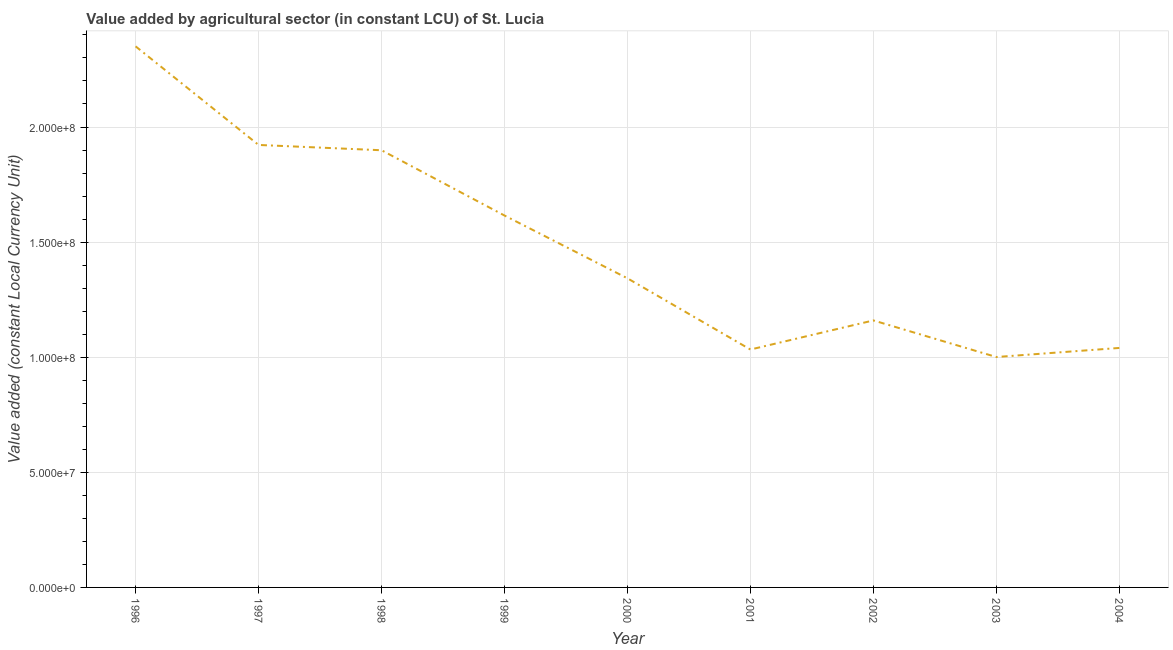What is the value added by agriculture sector in 2001?
Offer a very short reply. 1.03e+08. Across all years, what is the maximum value added by agriculture sector?
Offer a very short reply. 2.35e+08. Across all years, what is the minimum value added by agriculture sector?
Your answer should be compact. 1.00e+08. In which year was the value added by agriculture sector maximum?
Provide a short and direct response. 1996. What is the sum of the value added by agriculture sector?
Offer a terse response. 1.34e+09. What is the difference between the value added by agriculture sector in 1999 and 2000?
Your answer should be very brief. 2.73e+07. What is the average value added by agriculture sector per year?
Provide a short and direct response. 1.48e+08. What is the median value added by agriculture sector?
Your answer should be compact. 1.34e+08. In how many years, is the value added by agriculture sector greater than 160000000 LCU?
Keep it short and to the point. 4. Do a majority of the years between 1999 and 1997 (inclusive) have value added by agriculture sector greater than 190000000 LCU?
Your answer should be compact. No. What is the ratio of the value added by agriculture sector in 1998 to that in 2004?
Offer a terse response. 1.83. Is the difference between the value added by agriculture sector in 1998 and 2004 greater than the difference between any two years?
Your response must be concise. No. What is the difference between the highest and the second highest value added by agriculture sector?
Give a very brief answer. 4.28e+07. Is the sum of the value added by agriculture sector in 1997 and 1999 greater than the maximum value added by agriculture sector across all years?
Make the answer very short. Yes. What is the difference between the highest and the lowest value added by agriculture sector?
Your response must be concise. 1.35e+08. In how many years, is the value added by agriculture sector greater than the average value added by agriculture sector taken over all years?
Offer a very short reply. 4. Does the value added by agriculture sector monotonically increase over the years?
Provide a succinct answer. No. What is the difference between two consecutive major ticks on the Y-axis?
Give a very brief answer. 5.00e+07. What is the title of the graph?
Provide a short and direct response. Value added by agricultural sector (in constant LCU) of St. Lucia. What is the label or title of the X-axis?
Your answer should be very brief. Year. What is the label or title of the Y-axis?
Your answer should be compact. Value added (constant Local Currency Unit). What is the Value added (constant Local Currency Unit) in 1996?
Offer a very short reply. 2.35e+08. What is the Value added (constant Local Currency Unit) in 1997?
Keep it short and to the point. 1.92e+08. What is the Value added (constant Local Currency Unit) in 1998?
Provide a succinct answer. 1.90e+08. What is the Value added (constant Local Currency Unit) in 1999?
Your response must be concise. 1.62e+08. What is the Value added (constant Local Currency Unit) in 2000?
Provide a succinct answer. 1.34e+08. What is the Value added (constant Local Currency Unit) in 2001?
Your answer should be very brief. 1.03e+08. What is the Value added (constant Local Currency Unit) of 2002?
Your response must be concise. 1.16e+08. What is the Value added (constant Local Currency Unit) in 2003?
Keep it short and to the point. 1.00e+08. What is the Value added (constant Local Currency Unit) in 2004?
Give a very brief answer. 1.04e+08. What is the difference between the Value added (constant Local Currency Unit) in 1996 and 1997?
Your response must be concise. 4.28e+07. What is the difference between the Value added (constant Local Currency Unit) in 1996 and 1998?
Your answer should be compact. 4.51e+07. What is the difference between the Value added (constant Local Currency Unit) in 1996 and 1999?
Provide a succinct answer. 7.35e+07. What is the difference between the Value added (constant Local Currency Unit) in 1996 and 2000?
Offer a terse response. 1.01e+08. What is the difference between the Value added (constant Local Currency Unit) in 1996 and 2001?
Your answer should be compact. 1.32e+08. What is the difference between the Value added (constant Local Currency Unit) in 1996 and 2002?
Your answer should be compact. 1.19e+08. What is the difference between the Value added (constant Local Currency Unit) in 1996 and 2003?
Your answer should be compact. 1.35e+08. What is the difference between the Value added (constant Local Currency Unit) in 1996 and 2004?
Offer a very short reply. 1.31e+08. What is the difference between the Value added (constant Local Currency Unit) in 1997 and 1998?
Your answer should be very brief. 2.31e+06. What is the difference between the Value added (constant Local Currency Unit) in 1997 and 1999?
Your response must be concise. 3.07e+07. What is the difference between the Value added (constant Local Currency Unit) in 1997 and 2000?
Give a very brief answer. 5.79e+07. What is the difference between the Value added (constant Local Currency Unit) in 1997 and 2001?
Your answer should be compact. 8.89e+07. What is the difference between the Value added (constant Local Currency Unit) in 1997 and 2002?
Offer a very short reply. 7.62e+07. What is the difference between the Value added (constant Local Currency Unit) in 1997 and 2003?
Offer a terse response. 9.21e+07. What is the difference between the Value added (constant Local Currency Unit) in 1997 and 2004?
Provide a short and direct response. 8.82e+07. What is the difference between the Value added (constant Local Currency Unit) in 1998 and 1999?
Give a very brief answer. 2.83e+07. What is the difference between the Value added (constant Local Currency Unit) in 1998 and 2000?
Offer a terse response. 5.56e+07. What is the difference between the Value added (constant Local Currency Unit) in 1998 and 2001?
Your response must be concise. 8.66e+07. What is the difference between the Value added (constant Local Currency Unit) in 1998 and 2002?
Give a very brief answer. 7.39e+07. What is the difference between the Value added (constant Local Currency Unit) in 1998 and 2003?
Make the answer very short. 8.98e+07. What is the difference between the Value added (constant Local Currency Unit) in 1998 and 2004?
Give a very brief answer. 8.59e+07. What is the difference between the Value added (constant Local Currency Unit) in 1999 and 2000?
Ensure brevity in your answer.  2.73e+07. What is the difference between the Value added (constant Local Currency Unit) in 1999 and 2001?
Make the answer very short. 5.82e+07. What is the difference between the Value added (constant Local Currency Unit) in 1999 and 2002?
Make the answer very short. 4.56e+07. What is the difference between the Value added (constant Local Currency Unit) in 1999 and 2003?
Ensure brevity in your answer.  6.15e+07. What is the difference between the Value added (constant Local Currency Unit) in 1999 and 2004?
Keep it short and to the point. 5.75e+07. What is the difference between the Value added (constant Local Currency Unit) in 2000 and 2001?
Keep it short and to the point. 3.09e+07. What is the difference between the Value added (constant Local Currency Unit) in 2000 and 2002?
Offer a very short reply. 1.83e+07. What is the difference between the Value added (constant Local Currency Unit) in 2000 and 2003?
Provide a short and direct response. 3.42e+07. What is the difference between the Value added (constant Local Currency Unit) in 2000 and 2004?
Ensure brevity in your answer.  3.02e+07. What is the difference between the Value added (constant Local Currency Unit) in 2001 and 2002?
Give a very brief answer. -1.26e+07. What is the difference between the Value added (constant Local Currency Unit) in 2001 and 2003?
Your answer should be compact. 3.25e+06. What is the difference between the Value added (constant Local Currency Unit) in 2001 and 2004?
Your answer should be very brief. -6.90e+05. What is the difference between the Value added (constant Local Currency Unit) in 2002 and 2003?
Your answer should be very brief. 1.59e+07. What is the difference between the Value added (constant Local Currency Unit) in 2002 and 2004?
Ensure brevity in your answer.  1.20e+07. What is the difference between the Value added (constant Local Currency Unit) in 2003 and 2004?
Your answer should be very brief. -3.94e+06. What is the ratio of the Value added (constant Local Currency Unit) in 1996 to that in 1997?
Your answer should be compact. 1.22. What is the ratio of the Value added (constant Local Currency Unit) in 1996 to that in 1998?
Make the answer very short. 1.24. What is the ratio of the Value added (constant Local Currency Unit) in 1996 to that in 1999?
Your response must be concise. 1.46. What is the ratio of the Value added (constant Local Currency Unit) in 1996 to that in 2000?
Ensure brevity in your answer.  1.75. What is the ratio of the Value added (constant Local Currency Unit) in 1996 to that in 2001?
Offer a very short reply. 2.27. What is the ratio of the Value added (constant Local Currency Unit) in 1996 to that in 2002?
Ensure brevity in your answer.  2.03. What is the ratio of the Value added (constant Local Currency Unit) in 1996 to that in 2003?
Provide a succinct answer. 2.35. What is the ratio of the Value added (constant Local Currency Unit) in 1996 to that in 2004?
Offer a terse response. 2.26. What is the ratio of the Value added (constant Local Currency Unit) in 1997 to that in 1998?
Provide a short and direct response. 1.01. What is the ratio of the Value added (constant Local Currency Unit) in 1997 to that in 1999?
Provide a succinct answer. 1.19. What is the ratio of the Value added (constant Local Currency Unit) in 1997 to that in 2000?
Your answer should be very brief. 1.43. What is the ratio of the Value added (constant Local Currency Unit) in 1997 to that in 2001?
Provide a succinct answer. 1.86. What is the ratio of the Value added (constant Local Currency Unit) in 1997 to that in 2002?
Your answer should be very brief. 1.66. What is the ratio of the Value added (constant Local Currency Unit) in 1997 to that in 2003?
Your response must be concise. 1.92. What is the ratio of the Value added (constant Local Currency Unit) in 1997 to that in 2004?
Ensure brevity in your answer.  1.85. What is the ratio of the Value added (constant Local Currency Unit) in 1998 to that in 1999?
Offer a very short reply. 1.18. What is the ratio of the Value added (constant Local Currency Unit) in 1998 to that in 2000?
Keep it short and to the point. 1.41. What is the ratio of the Value added (constant Local Currency Unit) in 1998 to that in 2001?
Ensure brevity in your answer.  1.84. What is the ratio of the Value added (constant Local Currency Unit) in 1998 to that in 2002?
Provide a short and direct response. 1.64. What is the ratio of the Value added (constant Local Currency Unit) in 1998 to that in 2003?
Provide a succinct answer. 1.9. What is the ratio of the Value added (constant Local Currency Unit) in 1998 to that in 2004?
Your answer should be compact. 1.82. What is the ratio of the Value added (constant Local Currency Unit) in 1999 to that in 2000?
Your response must be concise. 1.2. What is the ratio of the Value added (constant Local Currency Unit) in 1999 to that in 2001?
Your answer should be compact. 1.56. What is the ratio of the Value added (constant Local Currency Unit) in 1999 to that in 2002?
Your response must be concise. 1.39. What is the ratio of the Value added (constant Local Currency Unit) in 1999 to that in 2003?
Provide a short and direct response. 1.61. What is the ratio of the Value added (constant Local Currency Unit) in 1999 to that in 2004?
Give a very brief answer. 1.55. What is the ratio of the Value added (constant Local Currency Unit) in 2000 to that in 2001?
Give a very brief answer. 1.3. What is the ratio of the Value added (constant Local Currency Unit) in 2000 to that in 2002?
Ensure brevity in your answer.  1.16. What is the ratio of the Value added (constant Local Currency Unit) in 2000 to that in 2003?
Your response must be concise. 1.34. What is the ratio of the Value added (constant Local Currency Unit) in 2000 to that in 2004?
Ensure brevity in your answer.  1.29. What is the ratio of the Value added (constant Local Currency Unit) in 2001 to that in 2002?
Keep it short and to the point. 0.89. What is the ratio of the Value added (constant Local Currency Unit) in 2001 to that in 2003?
Your response must be concise. 1.03. What is the ratio of the Value added (constant Local Currency Unit) in 2001 to that in 2004?
Provide a succinct answer. 0.99. What is the ratio of the Value added (constant Local Currency Unit) in 2002 to that in 2003?
Give a very brief answer. 1.16. What is the ratio of the Value added (constant Local Currency Unit) in 2002 to that in 2004?
Provide a succinct answer. 1.11. 